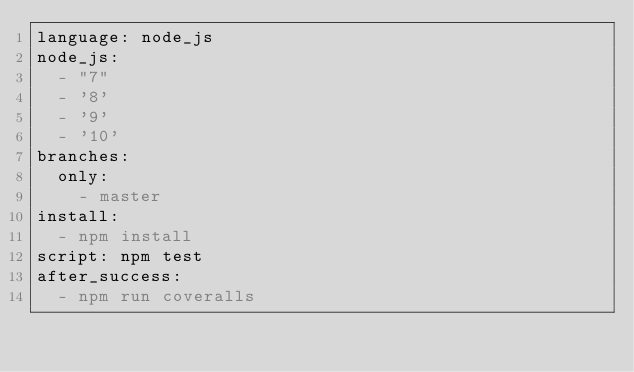Convert code to text. <code><loc_0><loc_0><loc_500><loc_500><_YAML_>language: node_js
node_js:
  - "7"
  - '8'
  - '9'
  - '10'
branches:
  only:
    - master
install:
  - npm install
script: npm test
after_success:
  - npm run coveralls</code> 